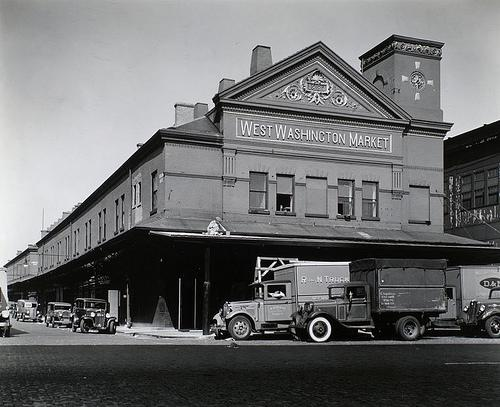Where are the trucks headed to? Please explain your reasoning. market. The trucks are used for transport. 